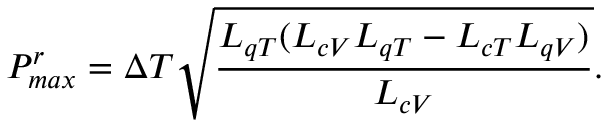Convert formula to latex. <formula><loc_0><loc_0><loc_500><loc_500>P _ { \max } ^ { r } = \Delta T \sqrt { \frac { L _ { q T } ( L _ { c V } L _ { q T } - L _ { c T } L _ { q V } ) } { L _ { c V } } } .</formula> 